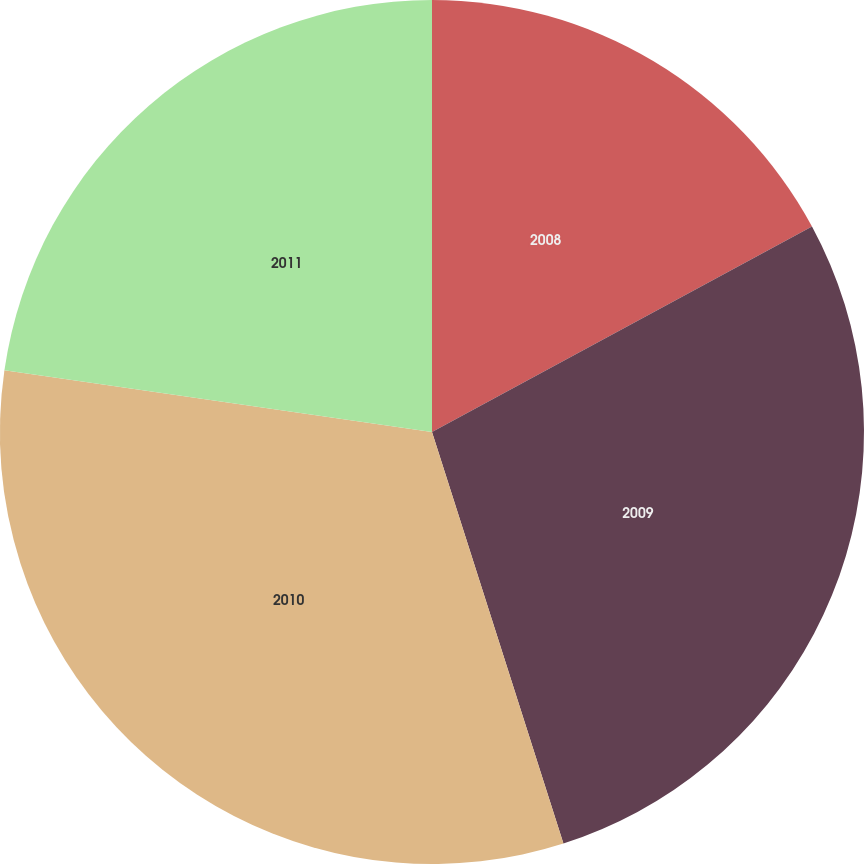Convert chart. <chart><loc_0><loc_0><loc_500><loc_500><pie_chart><fcel>2008<fcel>2009<fcel>2010<fcel>2011<nl><fcel>17.11%<fcel>27.97%<fcel>32.2%<fcel>22.72%<nl></chart> 